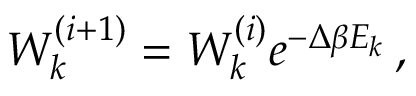Convert formula to latex. <formula><loc_0><loc_0><loc_500><loc_500>W _ { k } ^ { ( i + 1 ) } = W _ { k } ^ { ( i ) } e ^ { - \Delta \beta E _ { k } } \, ,</formula> 